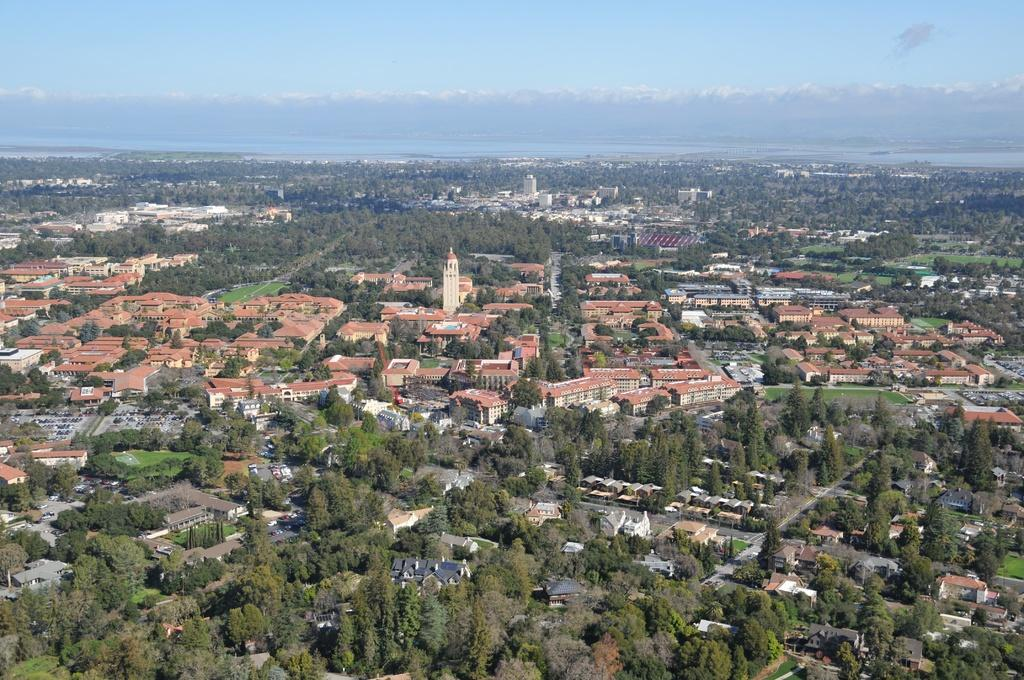What types of structures are visible in the image? There are buildings and houses in the image. What other natural elements can be seen in the image? There are trees in the image. What is visible in the sky in the image? The sky is visible in the image and appears to be cloudy. Can you see a snake slithering around the buildings in the image? No, there is no snake present in the image. 